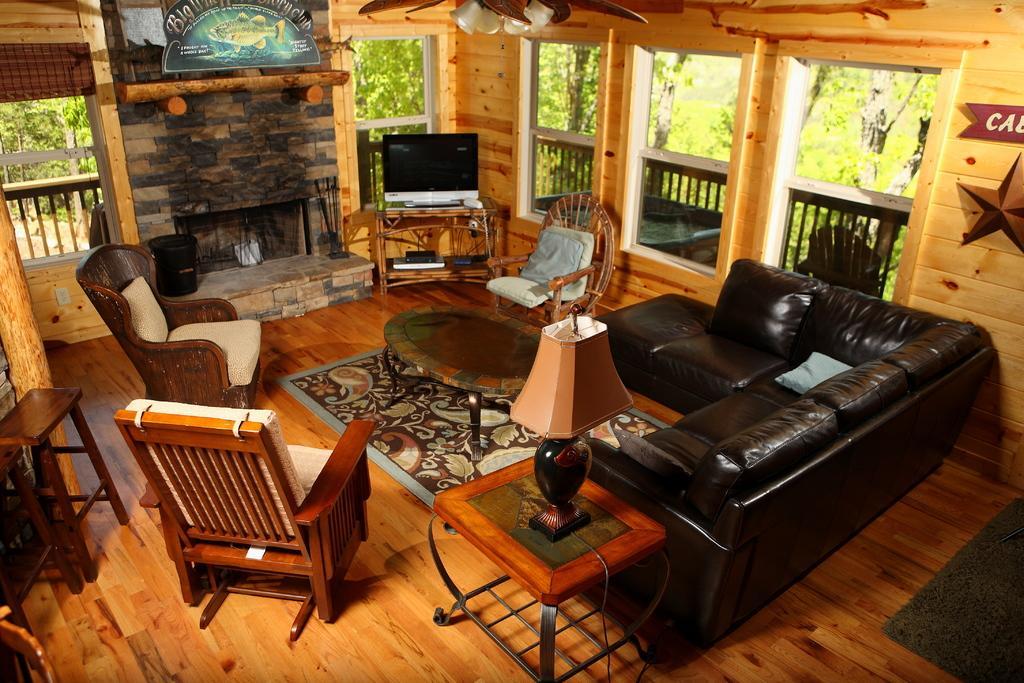Could you give a brief overview of what you see in this image? In this picture there is a room with a sofa and a fireplace, a chair, there is a window on the left and we can see trees from here and the floor is made of wooden 